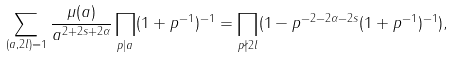<formula> <loc_0><loc_0><loc_500><loc_500>\sum _ { ( a , 2 l ) = 1 } \frac { \mu ( a ) } { a ^ { 2 + 2 s + 2 \alpha } } \prod _ { p | a } ( 1 + p ^ { - 1 } ) ^ { - 1 } = \prod _ { p \nmid 2 l } ( 1 - p ^ { - 2 - 2 \alpha - 2 s } ( 1 + p ^ { - 1 } ) ^ { - 1 } ) ,</formula> 